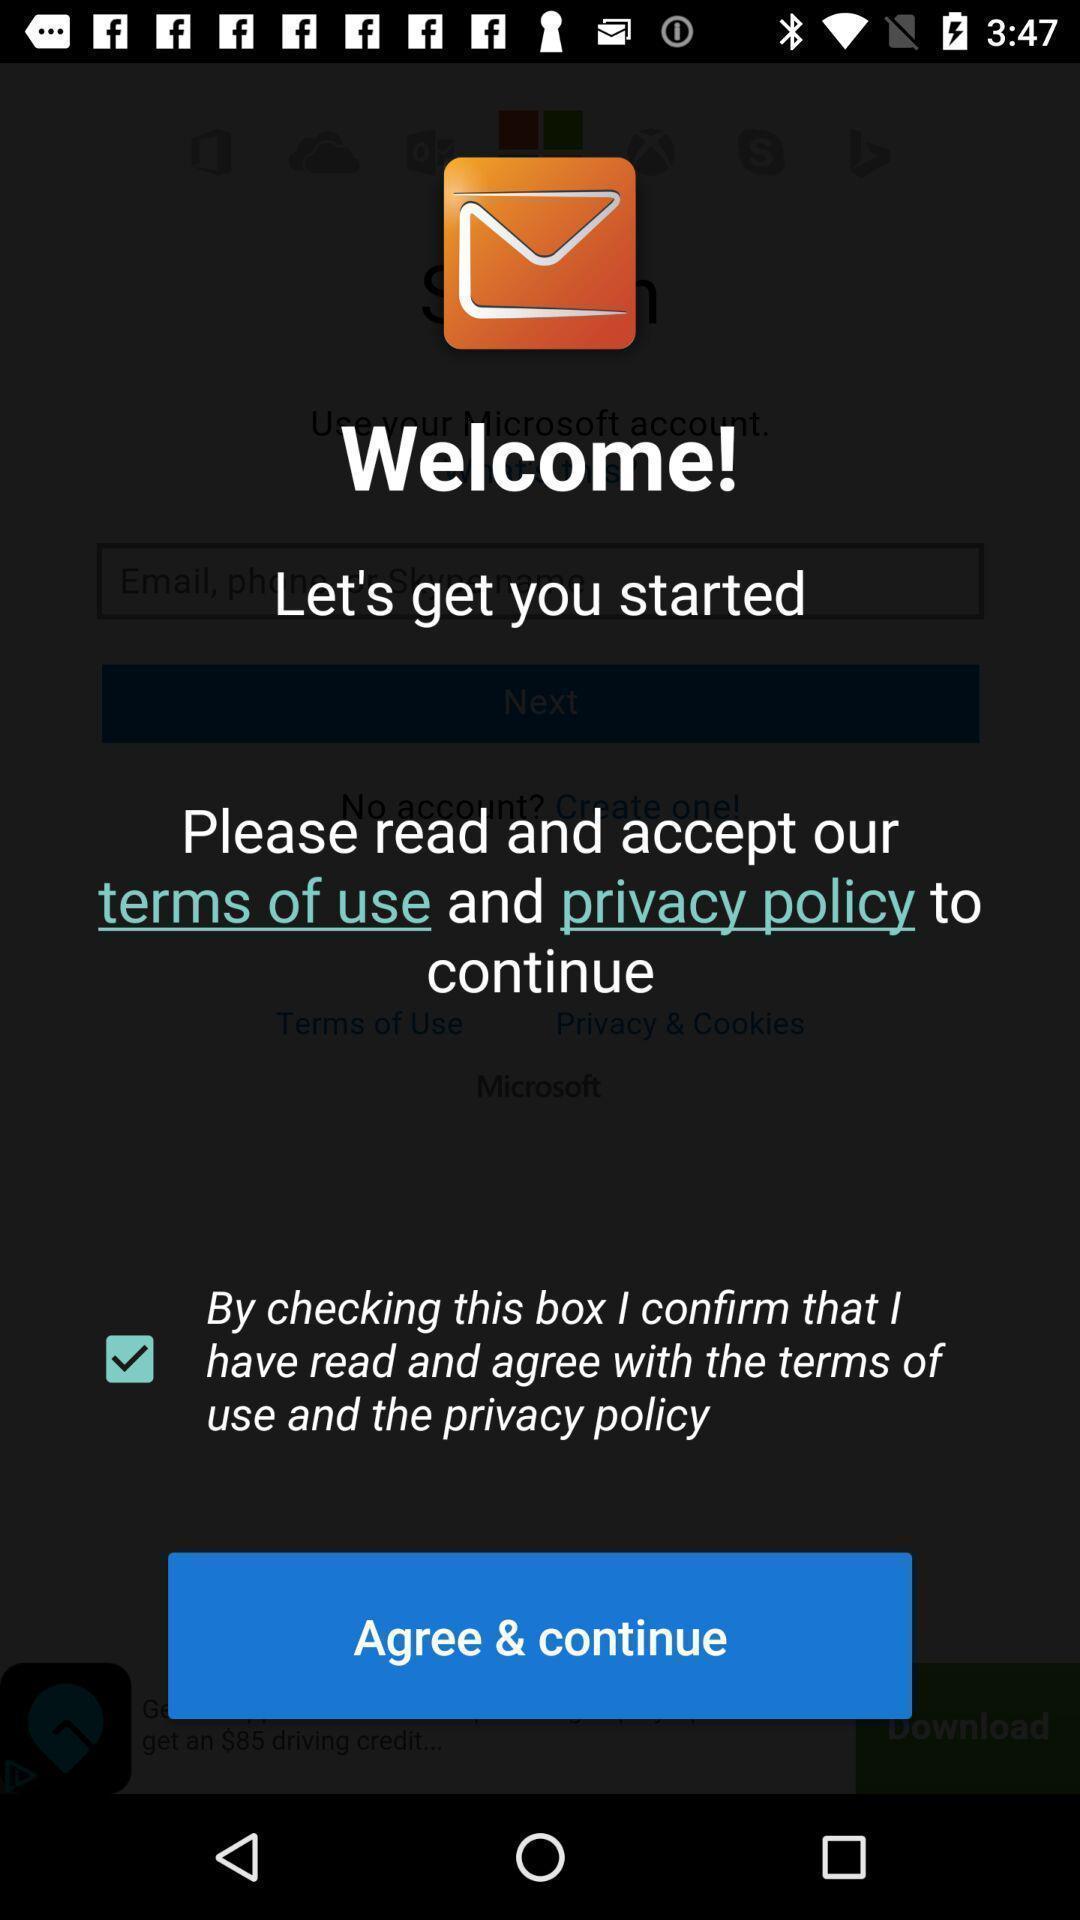What can you discern from this picture? Welcome page to agree terms of use. 